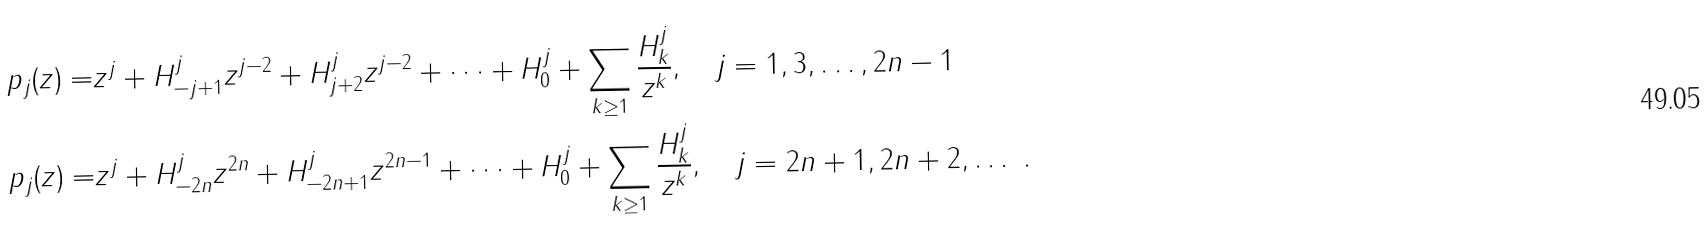Convert formula to latex. <formula><loc_0><loc_0><loc_500><loc_500>p _ { j } ( z ) = & z ^ { j } + H ^ { j } _ { - j + 1 } z ^ { j - 2 } + H ^ { j } _ { j + 2 } z ^ { j - 2 } + \dots + H ^ { j } _ { 0 } + \sum _ { k \geq 1 } \frac { H ^ { j } _ { k } } { z ^ { k } } , \quad j = 1 , 3 , \dots , 2 n - 1 \\ p _ { j } ( z ) = & z ^ { j } + H ^ { j } _ { - 2 n } z ^ { 2 n } + H ^ { j } _ { - 2 n + 1 } z ^ { 2 n - 1 } + \dots + H ^ { j } _ { 0 } + \sum _ { k \geq 1 } \frac { H ^ { j } _ { k } } { z ^ { k } } , \quad j = 2 n + 1 , 2 n + 2 , \dots \ .</formula> 